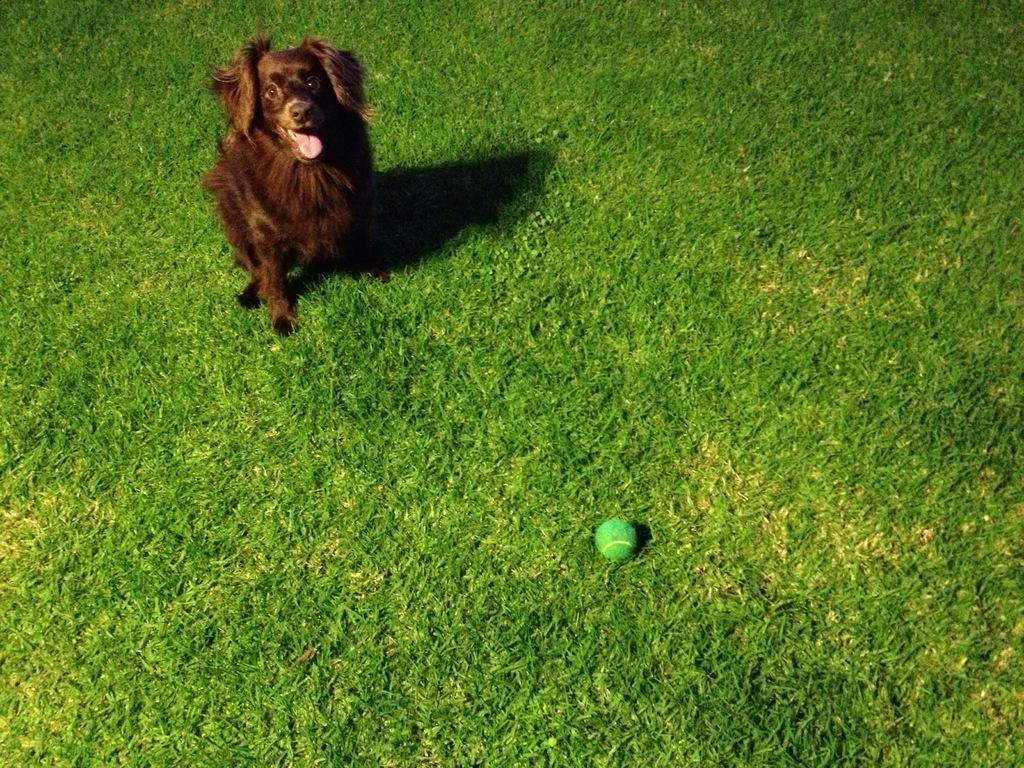Please provide a concise description of this image. In this picture we can see a dog and a ball on the grass. 